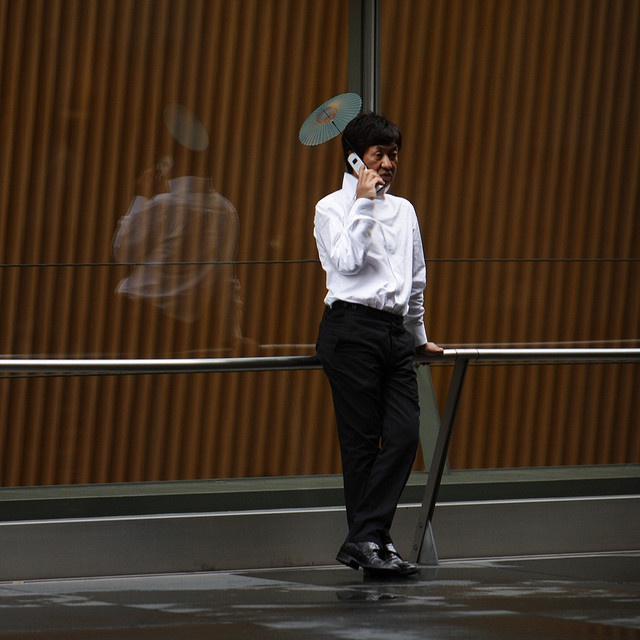Describe the objects in this image and their specific colors. I can see people in maroon, black, lavender, darkgray, and gray tones and cell phone in maroon, lightgray, darkgray, lightblue, and black tones in this image. 